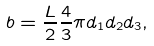Convert formula to latex. <formula><loc_0><loc_0><loc_500><loc_500>b = \frac { L } { 2 } \frac { 4 } { 3 } \pi d _ { 1 } d _ { 2 } d _ { 3 } ,</formula> 